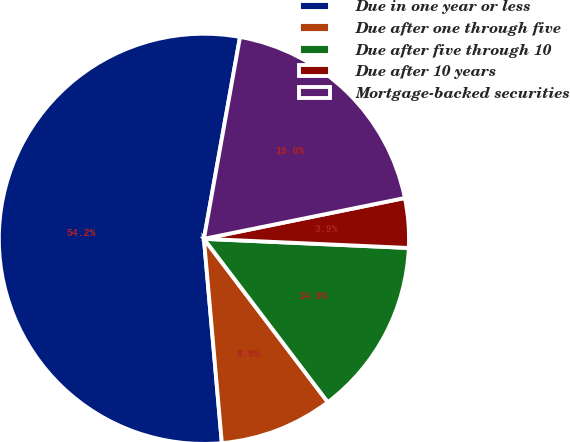Convert chart. <chart><loc_0><loc_0><loc_500><loc_500><pie_chart><fcel>Due in one year or less<fcel>Due after one through five<fcel>Due after five through 10<fcel>Due after 10 years<fcel>Mortgage-backed securities<nl><fcel>54.2%<fcel>8.93%<fcel>13.96%<fcel>3.9%<fcel>18.99%<nl></chart> 